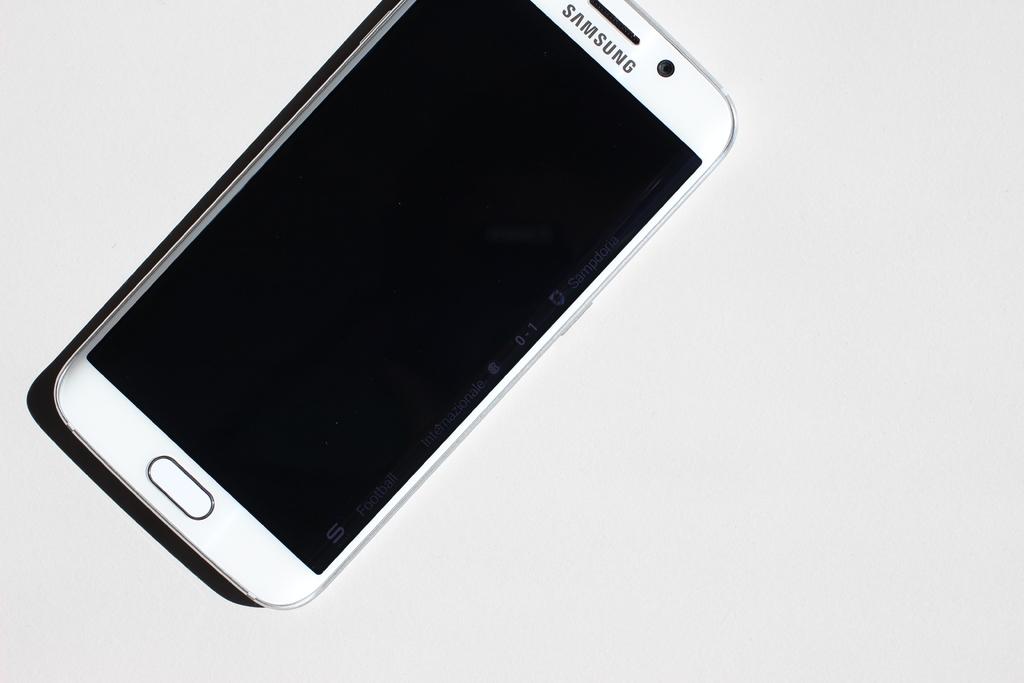What is the company who makes this smartphone?
Your answer should be compact. Samsung. 